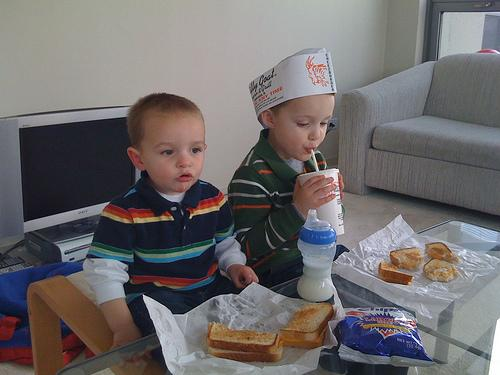What is the source of the melted product is in the center of sandwiches shown? cow 